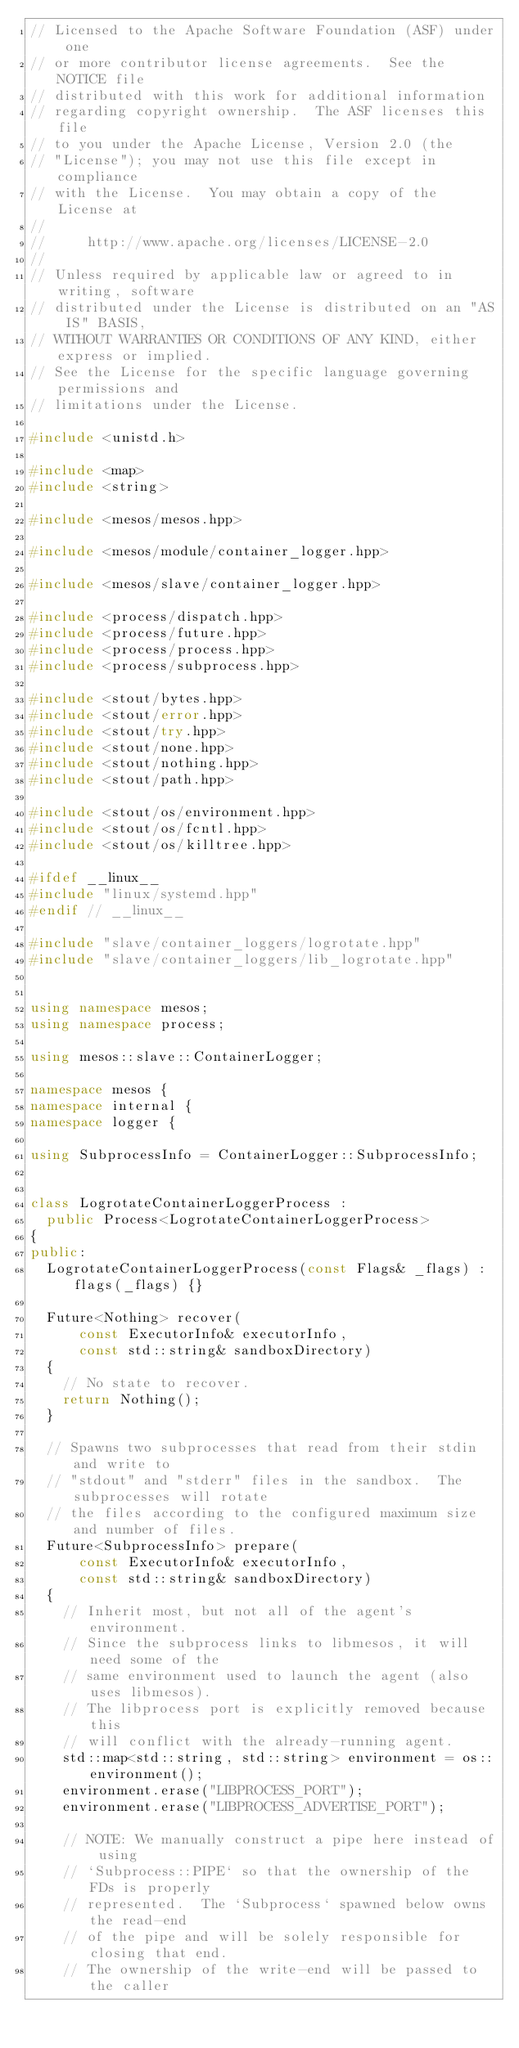<code> <loc_0><loc_0><loc_500><loc_500><_C++_>// Licensed to the Apache Software Foundation (ASF) under one
// or more contributor license agreements.  See the NOTICE file
// distributed with this work for additional information
// regarding copyright ownership.  The ASF licenses this file
// to you under the Apache License, Version 2.0 (the
// "License"); you may not use this file except in compliance
// with the License.  You may obtain a copy of the License at
//
//     http://www.apache.org/licenses/LICENSE-2.0
//
// Unless required by applicable law or agreed to in writing, software
// distributed under the License is distributed on an "AS IS" BASIS,
// WITHOUT WARRANTIES OR CONDITIONS OF ANY KIND, either express or implied.
// See the License for the specific language governing permissions and
// limitations under the License.

#include <unistd.h>

#include <map>
#include <string>

#include <mesos/mesos.hpp>

#include <mesos/module/container_logger.hpp>

#include <mesos/slave/container_logger.hpp>

#include <process/dispatch.hpp>
#include <process/future.hpp>
#include <process/process.hpp>
#include <process/subprocess.hpp>

#include <stout/bytes.hpp>
#include <stout/error.hpp>
#include <stout/try.hpp>
#include <stout/none.hpp>
#include <stout/nothing.hpp>
#include <stout/path.hpp>

#include <stout/os/environment.hpp>
#include <stout/os/fcntl.hpp>
#include <stout/os/killtree.hpp>

#ifdef __linux__
#include "linux/systemd.hpp"
#endif // __linux__

#include "slave/container_loggers/logrotate.hpp"
#include "slave/container_loggers/lib_logrotate.hpp"


using namespace mesos;
using namespace process;

using mesos::slave::ContainerLogger;

namespace mesos {
namespace internal {
namespace logger {

using SubprocessInfo = ContainerLogger::SubprocessInfo;


class LogrotateContainerLoggerProcess :
  public Process<LogrotateContainerLoggerProcess>
{
public:
  LogrotateContainerLoggerProcess(const Flags& _flags) : flags(_flags) {}

  Future<Nothing> recover(
      const ExecutorInfo& executorInfo,
      const std::string& sandboxDirectory)
  {
    // No state to recover.
    return Nothing();
  }

  // Spawns two subprocesses that read from their stdin and write to
  // "stdout" and "stderr" files in the sandbox.  The subprocesses will rotate
  // the files according to the configured maximum size and number of files.
  Future<SubprocessInfo> prepare(
      const ExecutorInfo& executorInfo,
      const std::string& sandboxDirectory)
  {
    // Inherit most, but not all of the agent's environment.
    // Since the subprocess links to libmesos, it will need some of the
    // same environment used to launch the agent (also uses libmesos).
    // The libprocess port is explicitly removed because this
    // will conflict with the already-running agent.
    std::map<std::string, std::string> environment = os::environment();
    environment.erase("LIBPROCESS_PORT");
    environment.erase("LIBPROCESS_ADVERTISE_PORT");

    // NOTE: We manually construct a pipe here instead of using
    // `Subprocess::PIPE` so that the ownership of the FDs is properly
    // represented.  The `Subprocess` spawned below owns the read-end
    // of the pipe and will be solely responsible for closing that end.
    // The ownership of the write-end will be passed to the caller</code> 